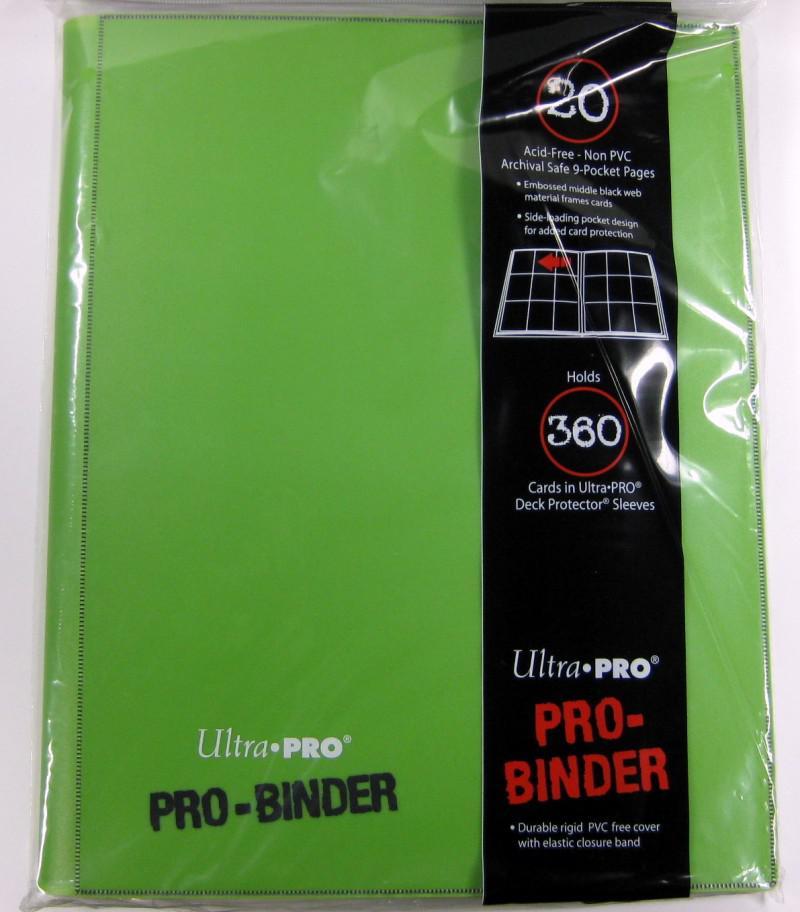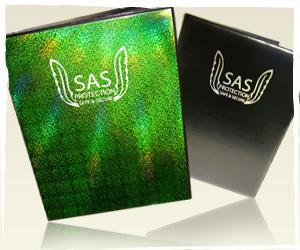The first image is the image on the left, the second image is the image on the right. Considering the images on both sides, is "The right image shows two binders." valid? Answer yes or no. Yes. 